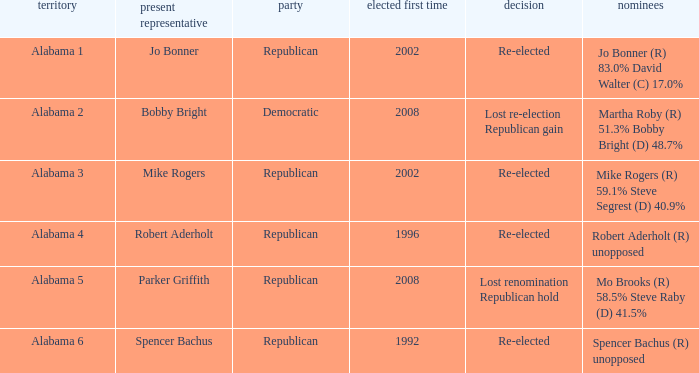Name the incumbent for alabama 6 Spencer Bachus. 